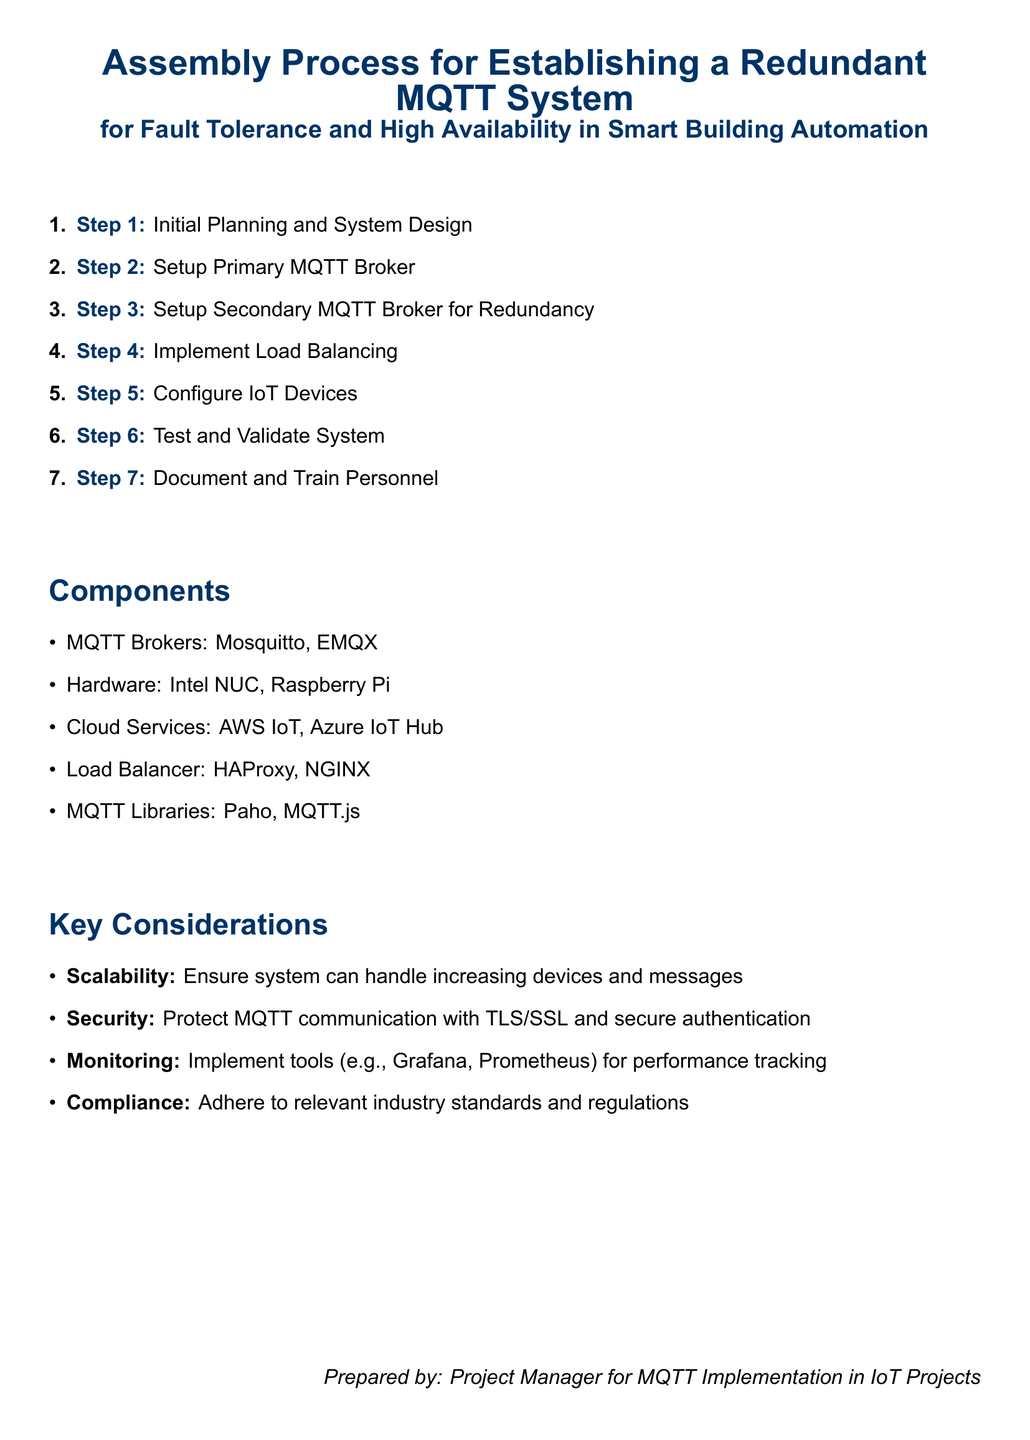What is the first step in the assembly process? The first step in the assembly process is outlined as "Initial Planning and System Design."
Answer: Initial Planning and System Design Which component is mentioned as a load balancer? The document lists HAProxy and NGINX as load balancer options.
Answer: HAProxy, NGINX What is one of the key considerations for the MQTT system? The document highlights scalability, security, monitoring, and compliance as key considerations.
Answer: Scalability How many steps are there in the assembly process? The document enumerates seven steps in the assembly process for establishing a redundant MQTT system.
Answer: 7 Which MQTT broker is specified for the primary setup? The document specifically mentions setting up a primary MQTT broker, but does not specify which one at this point.
Answer: Not specified What type of services is mentioned in the components section? The document mentions AWS IoT and Azure IoT Hub as cloud services in the components section.
Answer: AWS IoT, Azure IoT Hub What is the purpose of the secondary MQTT broker? The secondary MQTT broker is established for redundancy in the MQTT system.
Answer: Redundancy What MQTT library is listed in the components section? The document mentions Paho and MQTT.js as MQTT libraries in the components section.
Answer: Paho, MQTT.js 